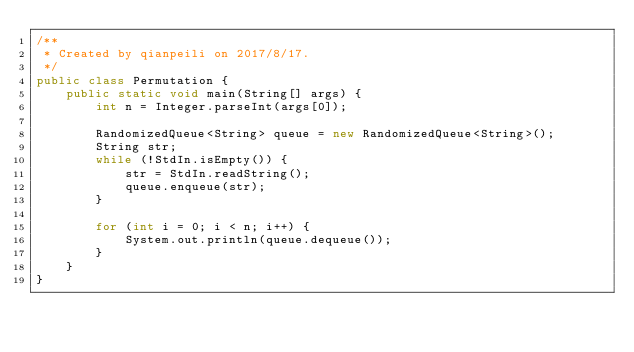Convert code to text. <code><loc_0><loc_0><loc_500><loc_500><_Java_>/**
 * Created by qianpeili on 2017/8/17.
 */
public class Permutation {
    public static void main(String[] args) {
        int n = Integer.parseInt(args[0]);

        RandomizedQueue<String> queue = new RandomizedQueue<String>();
        String str;
        while (!StdIn.isEmpty()) {
            str = StdIn.readString();
            queue.enqueue(str);
        }

        for (int i = 0; i < n; i++) {
            System.out.println(queue.dequeue());
        }
    }
}
</code> 